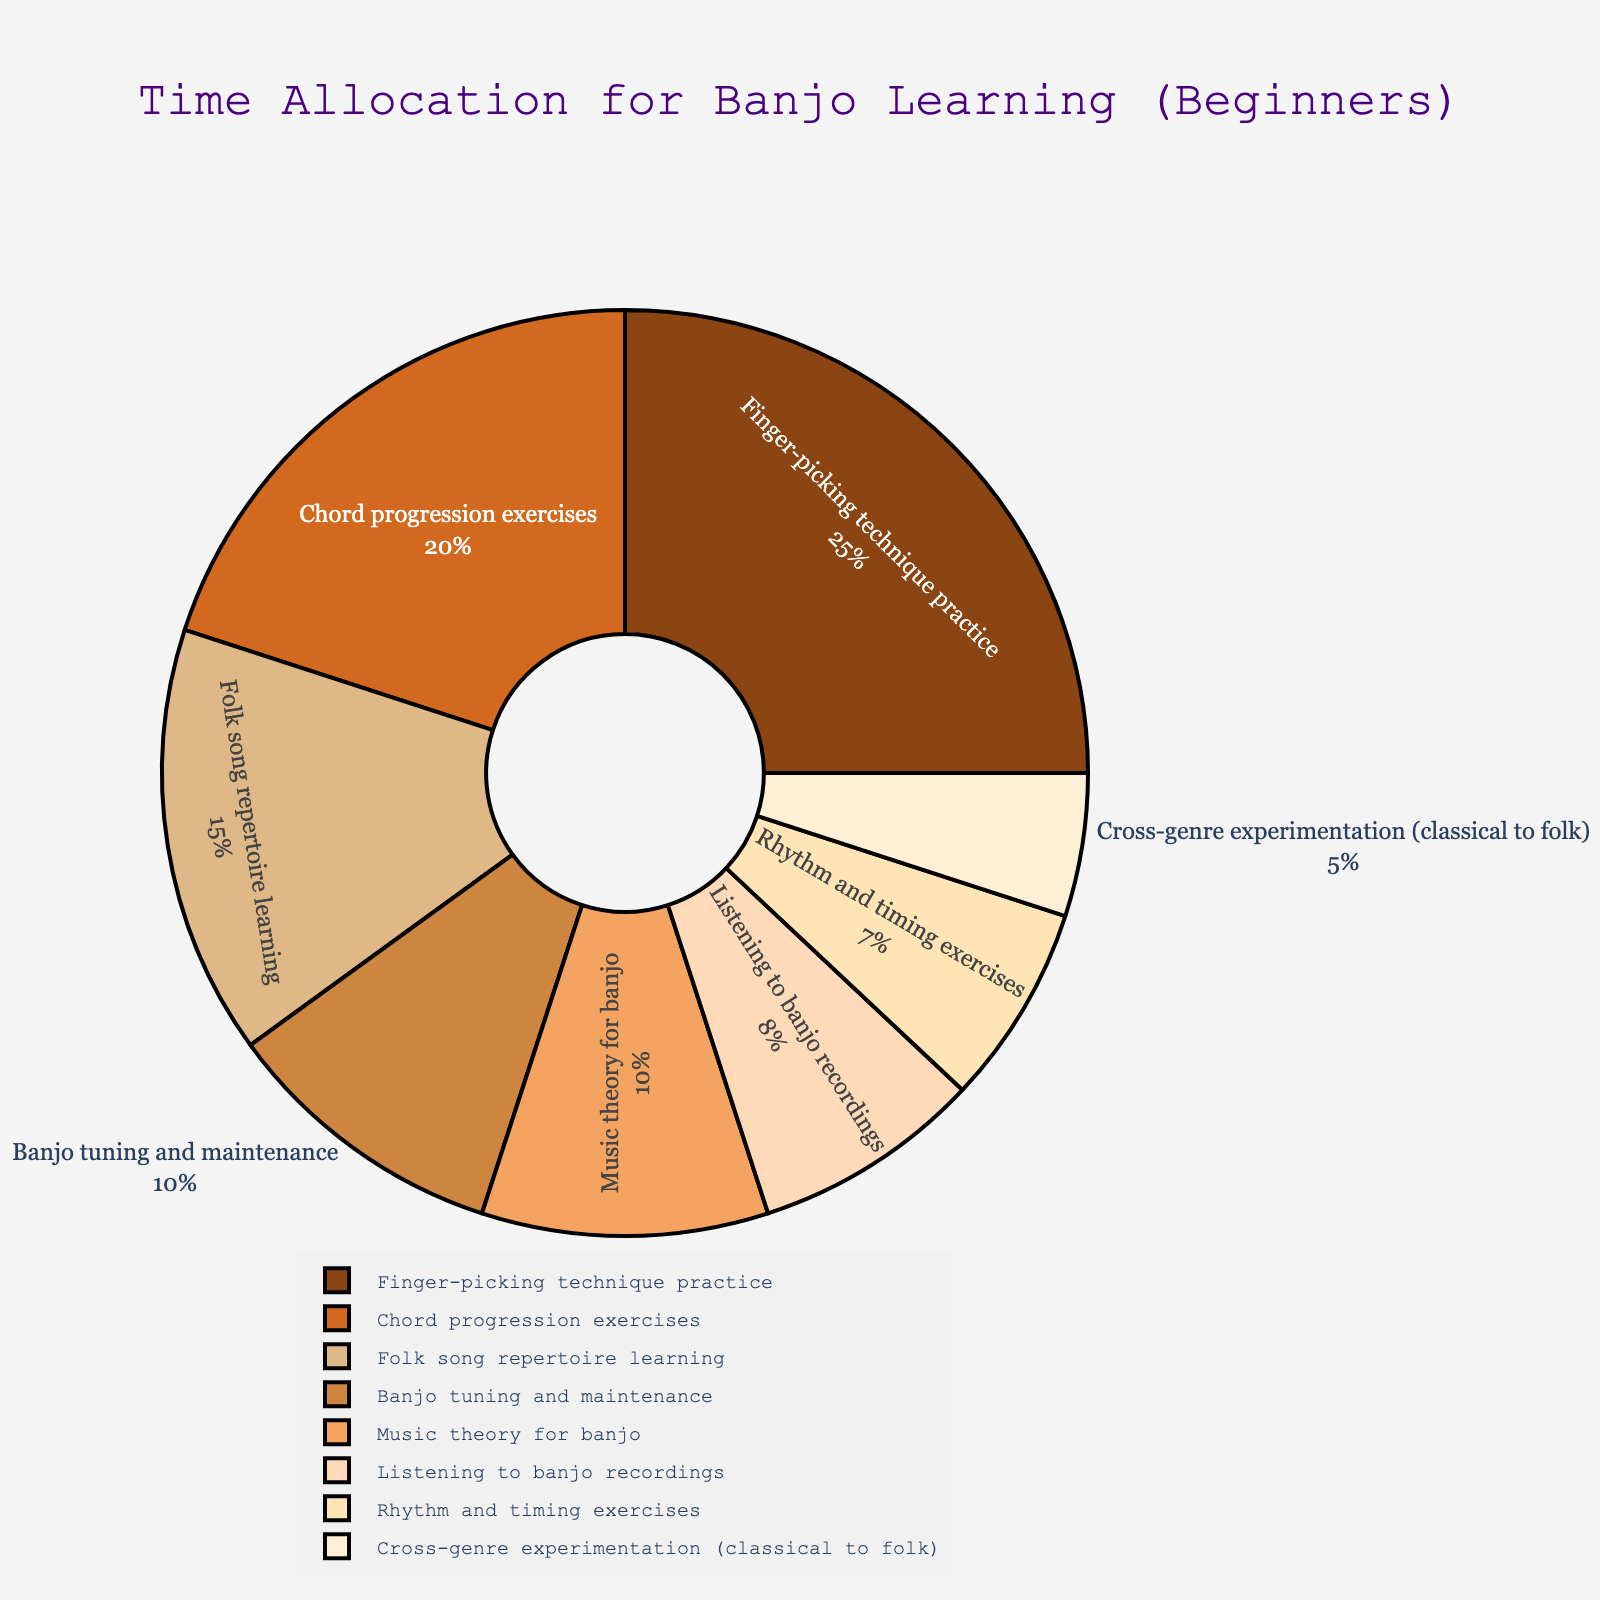What activity takes up the largest percentage of time? The largest segment of the pie chart is identified by the label "Finger-picking technique practice" with 25% indicated. This is the largest percentage among all activities listed.
Answer: Finger-picking technique practice What is the combined percentage of time spent on 'Finger-picking technique practice' and 'Chord progression exercises'? Look at the sections labeled "Finger-picking technique practice" and "Chord progression exercises." They are 25% and 20% respectively. Sum these percentages: 25% + 20% = 45%.
Answer: 45% How much more time is allocated to 'Folk song repertoire learning' compared to 'Rhythm and timing exercises'? First identify the percentages for both activities. "Folk song repertoire learning" is 15% and "Rhythm and timing exercises" is 7%. Find the difference by subtracting 7% from 15%: 15% - 7% = 8%.
Answer: 8% Is more time allocated to 'Listening to banjo recordings' or 'Cross-genre experimentation (classical to folk)'? Find the sections labeled "Listening to banjo recordings" (8%) and "Cross-genre experimentation (classical to folk)" (5%). Compare the two values; 8% is greater than 5%.
Answer: Listening to banjo recordings Which activity takes up the smallest portion of time, and how much time does it take? The smallest section of the pie chart is labeled as "Cross-genre experimentation (classical to folk)" with 5% indicated.
Answer: Cross-genre experimentation (classical to folk), 5% What is the total percentage of time spent on activities related to technique (i.e., 'Finger-picking technique practice' and 'Chord progression exercises') and theoretical knowledge ('Music theory for banjo')? Identify the percentages for "Finger-picking technique practice" (25%), "Chord progression exercises" (20%), and "Music theory for banjo" (10%). Sum them up: 25% + 20% + 10% = 55%.
Answer: 55% How much more time is spent on 'Banjo tuning and maintenance' than on 'Rhythm and timing exercises'? "Banjo tuning and maintenance" is 10% and "Rhythm and timing exercises" is 7%. Subtract 7% from 10%: 10% - 7% = 3%.
Answer: 3% Are there more activities that have a percentage greater than or equal to 15% or less than 15%? Count the activities with percentages greater than or equal to 15% ("Finger-picking technique practice" - 25%, "Chord progression exercises" - 20%, "Folk song repertoire learning" - 15%) and those less than 15% (remaining activities). There are 3 activities with ≥ 15%, and 5 activities with < 15%.
Answer: Less than 15% What is the average percentage allocated to 'Listening to banjo recordings,' 'Rhythm and timing exercises,' and 'Cross-genre experimentation (classical to folk)'? Identify the percentages: "Listening to banjo recordings" (8%), "Rhythm and timing exercises" (7%), and "Cross-genre experimentation (classical to folk)" (5%). Calculate the sum: 8% + 7% + 5% = 20%. Divide by the number of activities (3): 20% / 3 = approximately 6.67%.
Answer: 6.67% What two activities each take 10% of the time? Identify the sections labeled with 10%: "Banjo tuning and maintenance" and "Music theory for banjo" each occupy 10% of the total time.
Answer: Banjo tuning and maintenance, Music theory for banjo 